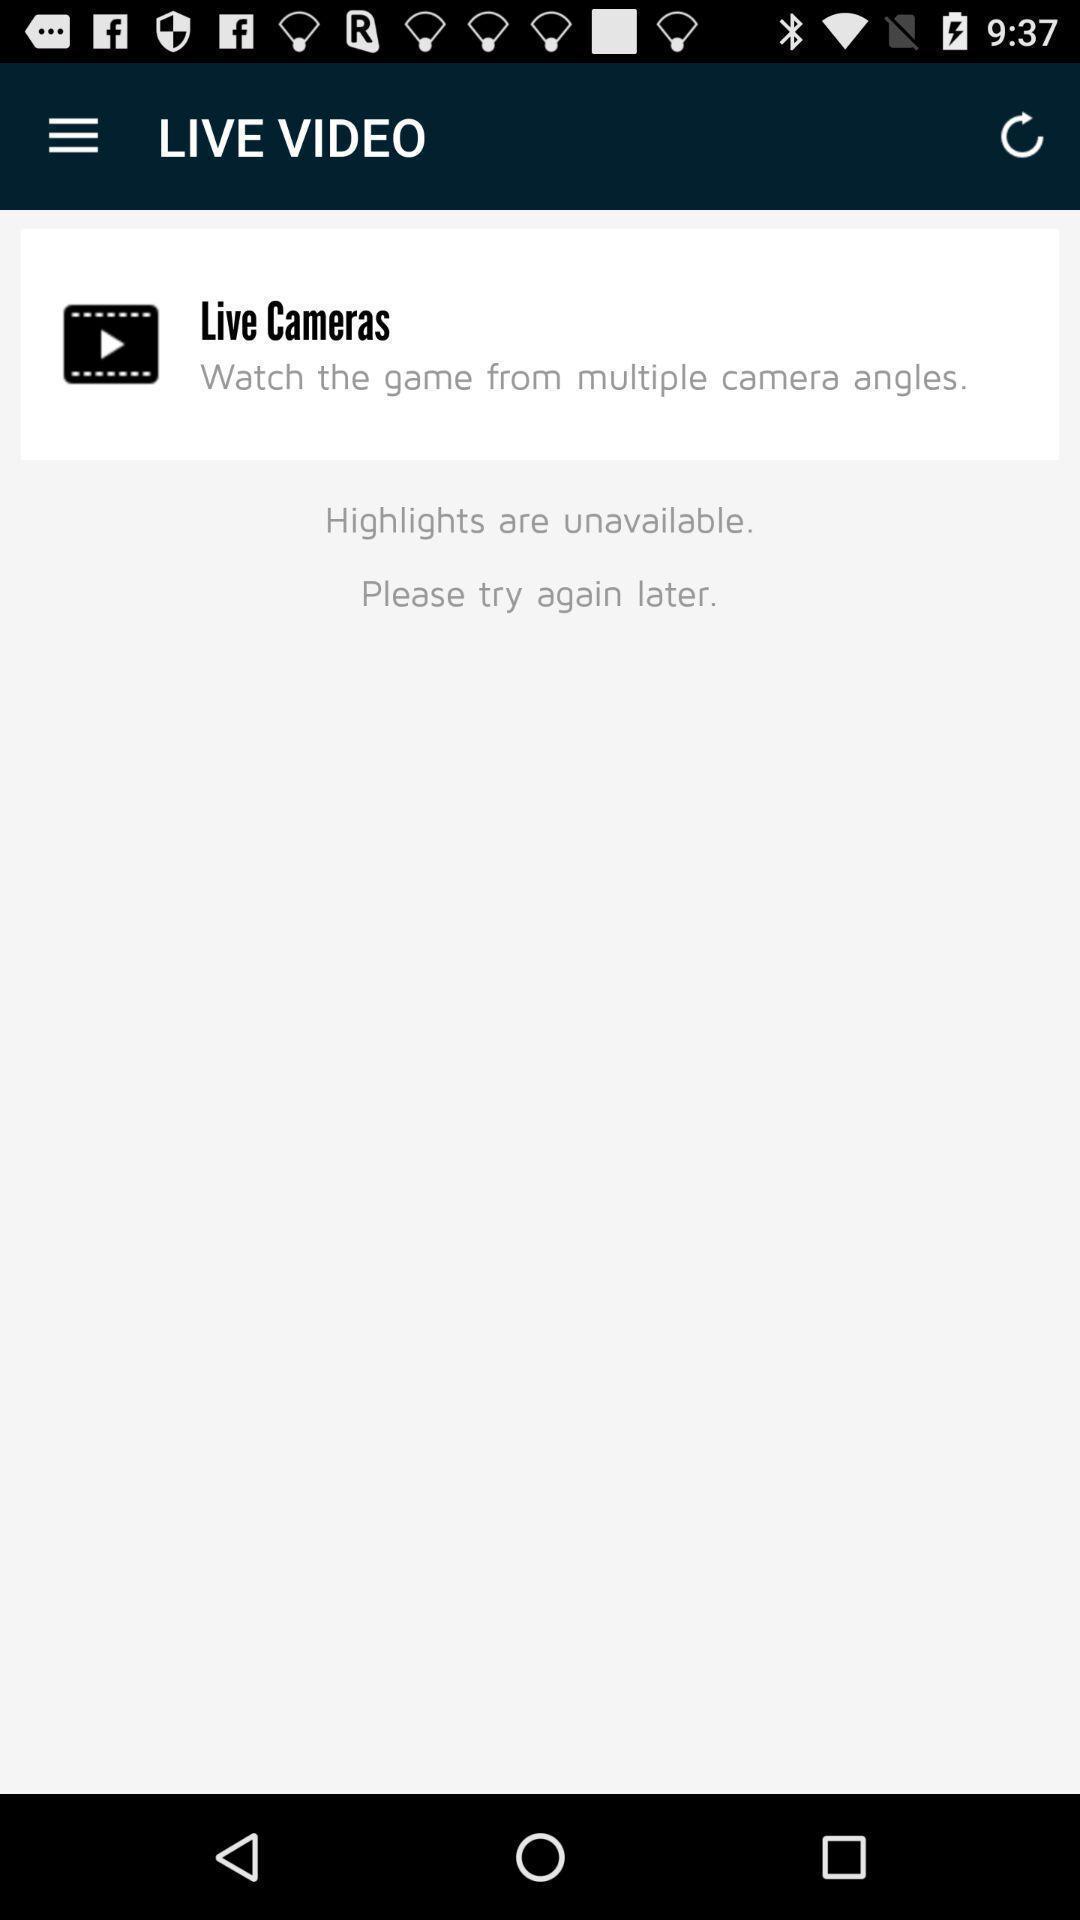Provide a detailed account of this screenshot. Screen displaying features information of a sports application. 